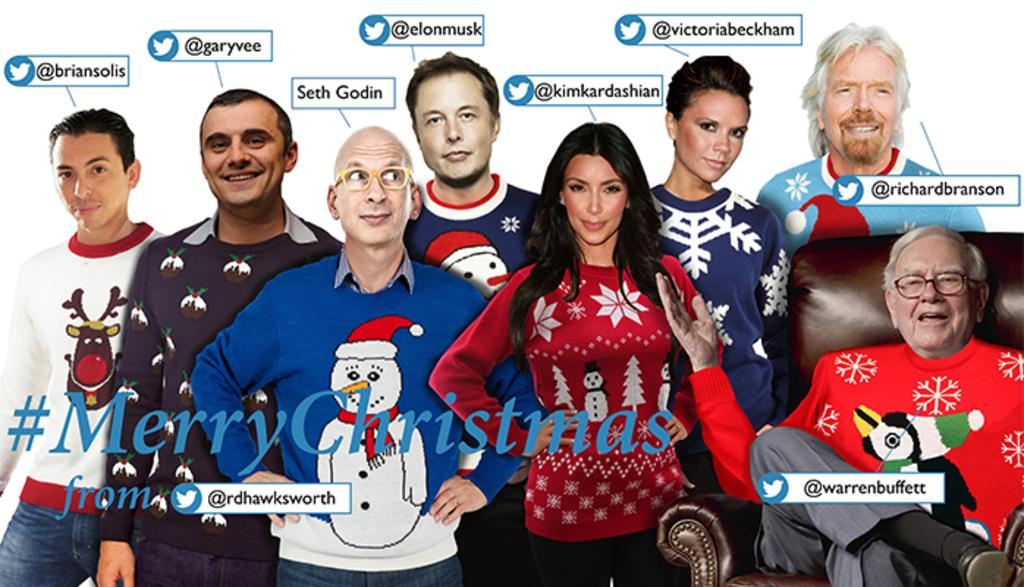Provide a one-sentence caption for the provided image. A collage of different celebrities share a card which reads Merry Christmas. 